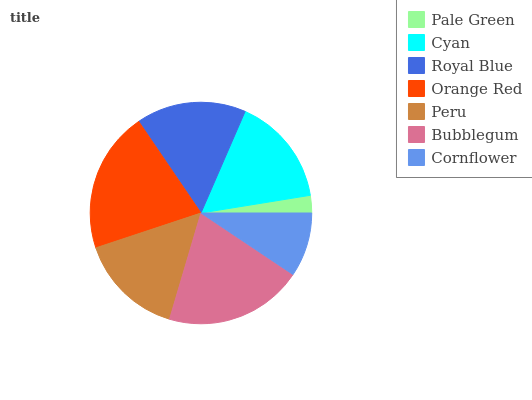Is Pale Green the minimum?
Answer yes or no. Yes. Is Orange Red the maximum?
Answer yes or no. Yes. Is Cyan the minimum?
Answer yes or no. No. Is Cyan the maximum?
Answer yes or no. No. Is Cyan greater than Pale Green?
Answer yes or no. Yes. Is Pale Green less than Cyan?
Answer yes or no. Yes. Is Pale Green greater than Cyan?
Answer yes or no. No. Is Cyan less than Pale Green?
Answer yes or no. No. Is Cyan the high median?
Answer yes or no. Yes. Is Cyan the low median?
Answer yes or no. Yes. Is Royal Blue the high median?
Answer yes or no. No. Is Peru the low median?
Answer yes or no. No. 